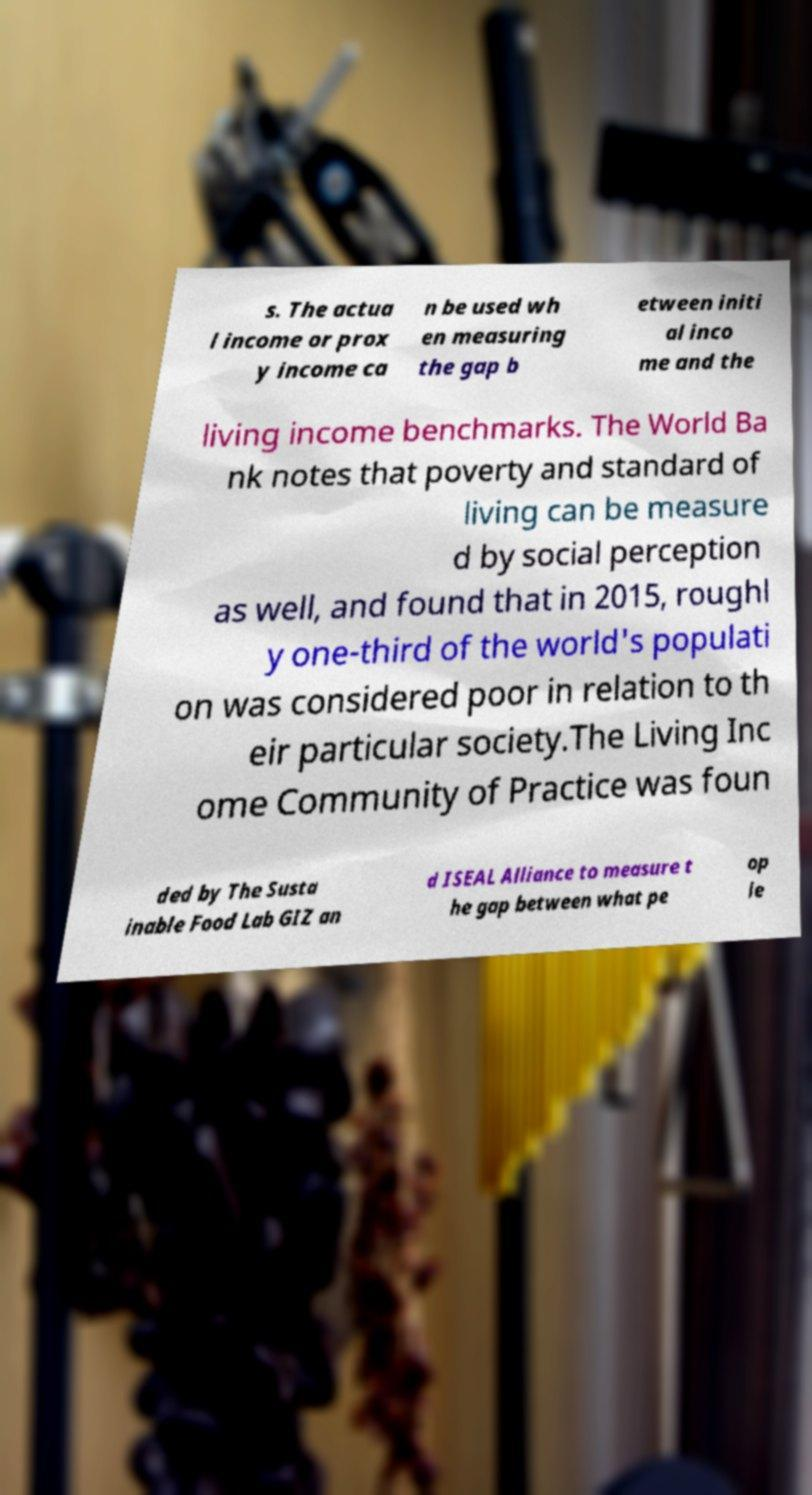Please read and relay the text visible in this image. What does it say? s. The actua l income or prox y income ca n be used wh en measuring the gap b etween initi al inco me and the living income benchmarks. The World Ba nk notes that poverty and standard of living can be measure d by social perception as well, and found that in 2015, roughl y one-third of the world's populati on was considered poor in relation to th eir particular society.The Living Inc ome Community of Practice was foun ded by The Susta inable Food Lab GIZ an d ISEAL Alliance to measure t he gap between what pe op le 